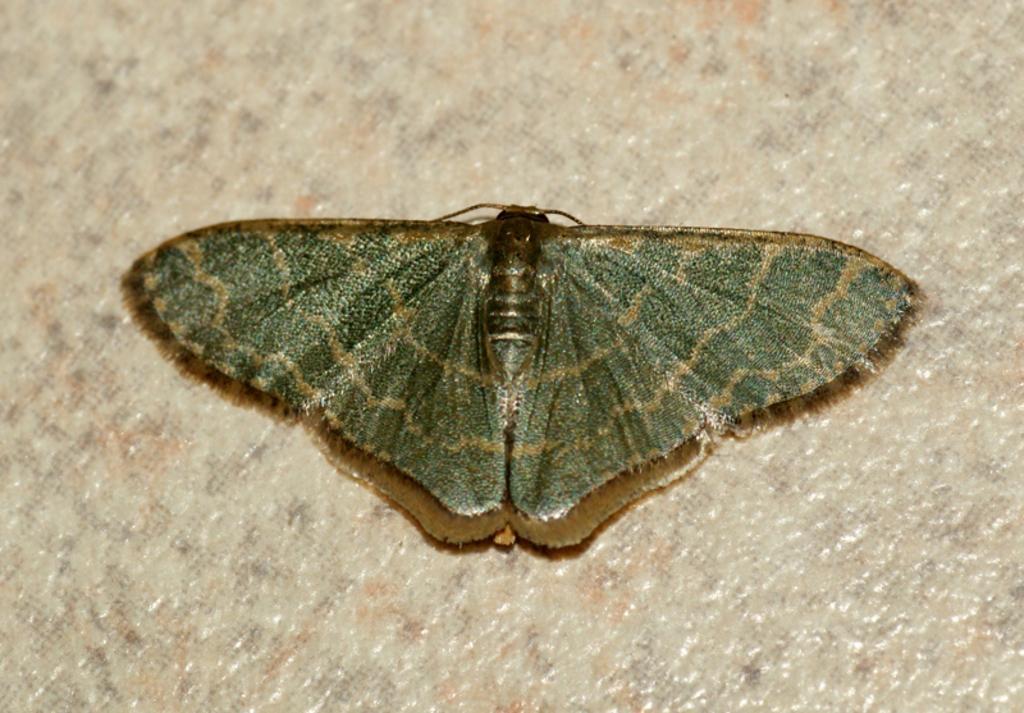Can you describe this image briefly? This image consists of a butterfly which is in the center. 